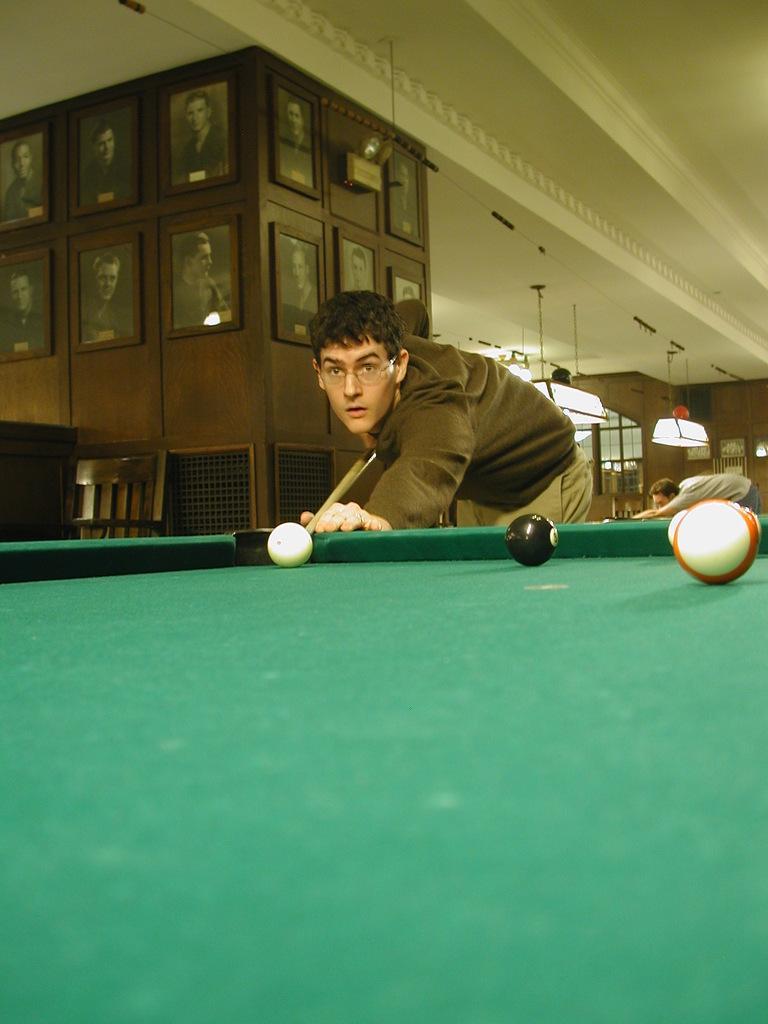How would you summarize this image in a sentence or two? In this picture there is a man holding a stick and hitting a ball. There are few balls on the tennis table. There are frames There is also another man. There is light, chair. 